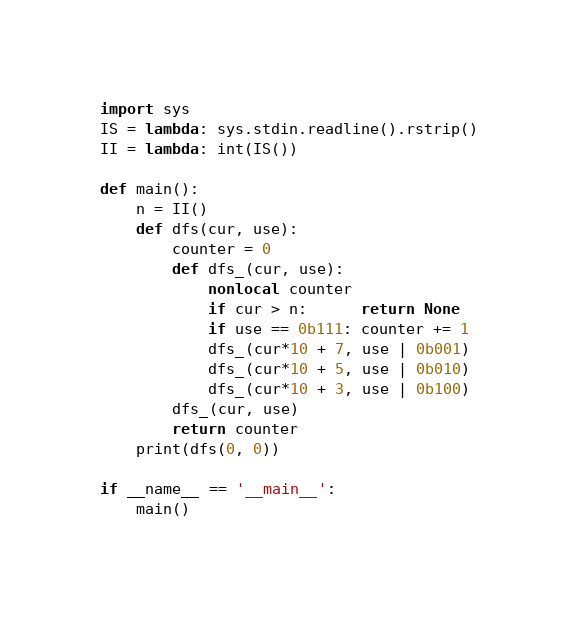Convert code to text. <code><loc_0><loc_0><loc_500><loc_500><_Python_>import sys
IS = lambda: sys.stdin.readline().rstrip()
II = lambda: int(IS())

def main():
    n = II()
    def dfs(cur, use):
        counter = 0
        def dfs_(cur, use):
            nonlocal counter
            if cur > n:      return None
            if use == 0b111: counter += 1
            dfs_(cur*10 + 7, use | 0b001)
            dfs_(cur*10 + 5, use | 0b010)
            dfs_(cur*10 + 3, use | 0b100)
        dfs_(cur, use)
        return counter
    print(dfs(0, 0))

if __name__ == '__main__':
    main()</code> 